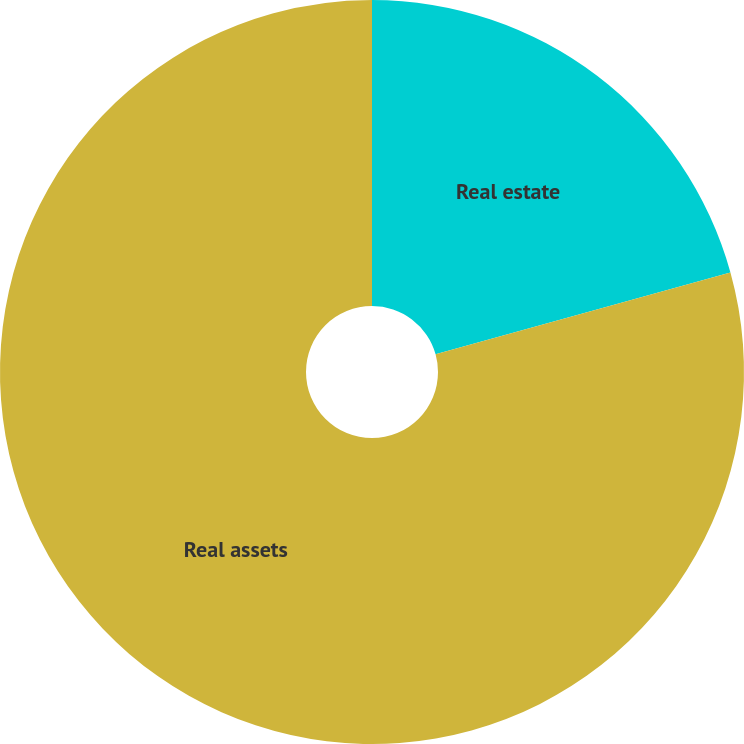Convert chart. <chart><loc_0><loc_0><loc_500><loc_500><pie_chart><fcel>Real estate<fcel>Real assets<nl><fcel>20.69%<fcel>79.31%<nl></chart> 